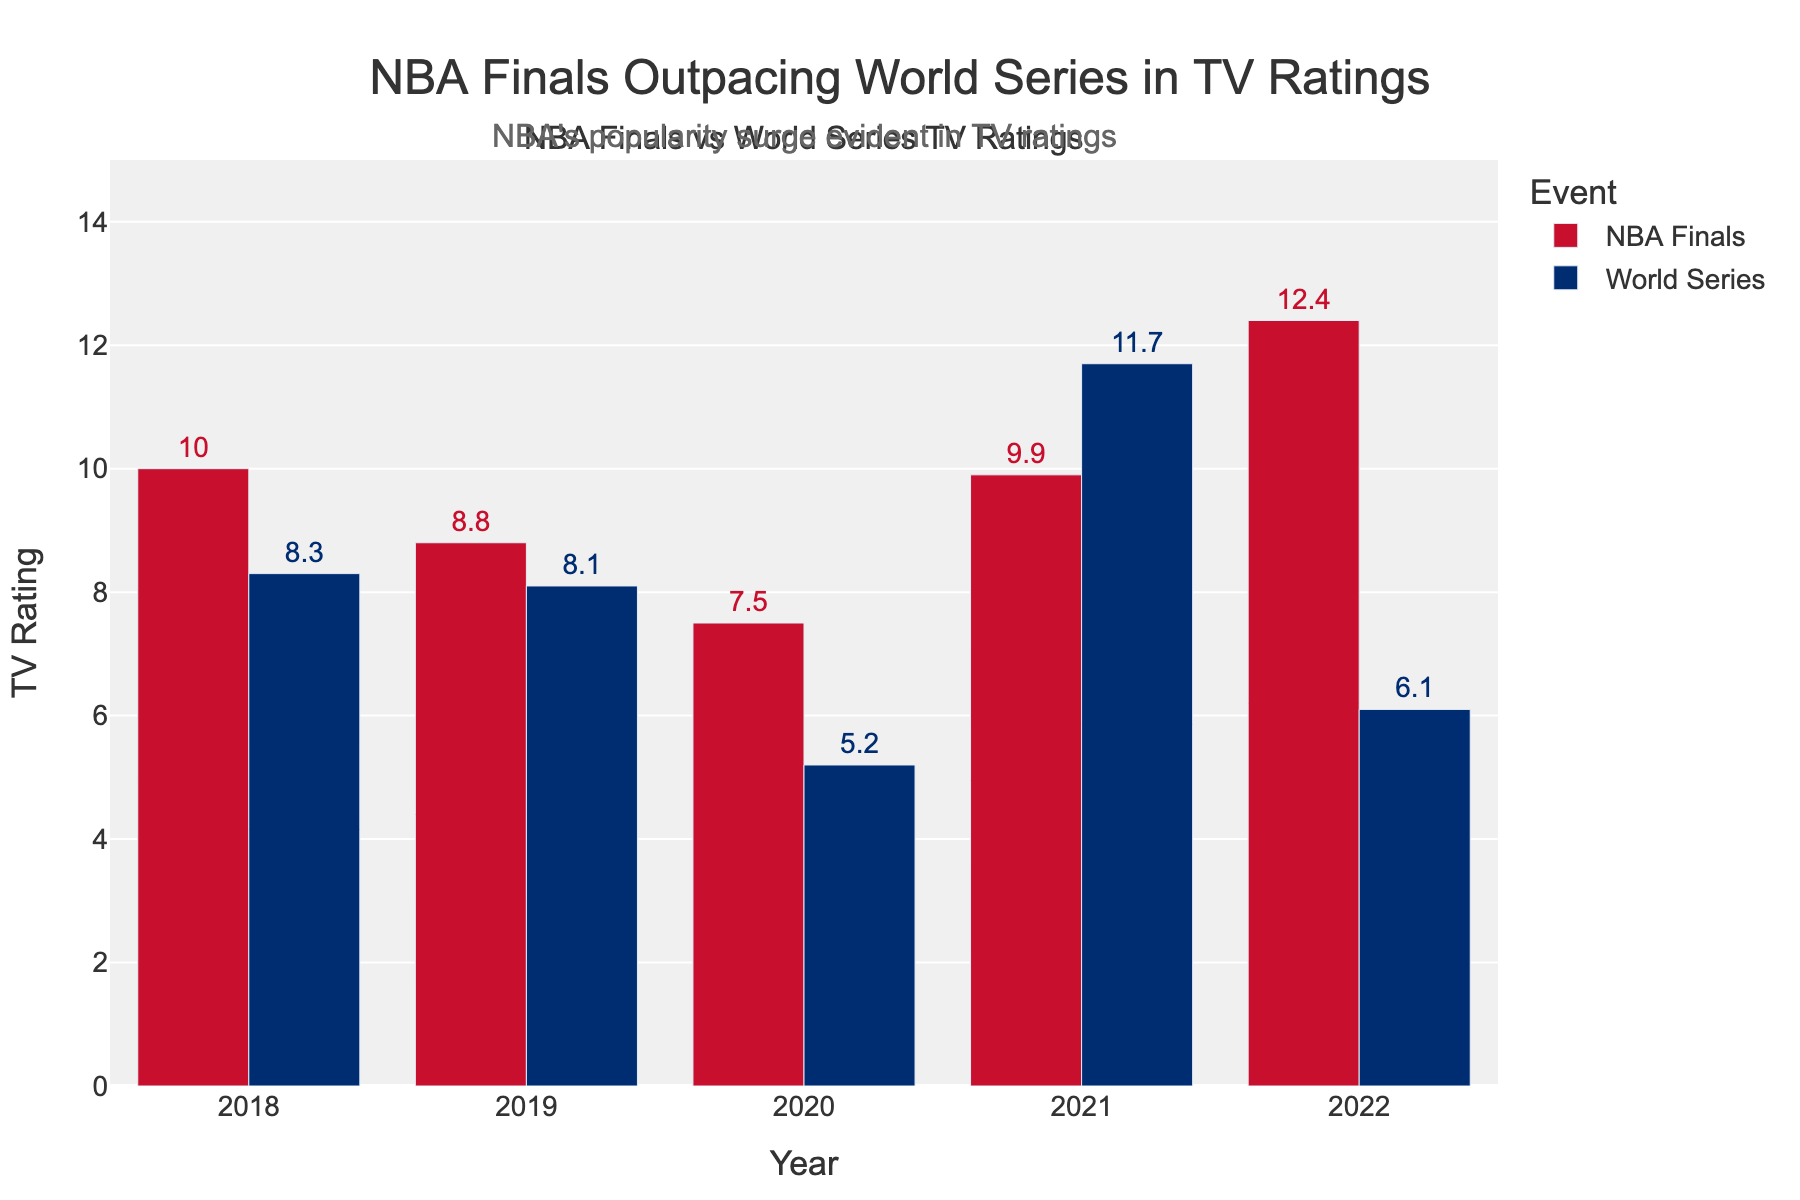What trend is evident from the NBA Finals' TV ratings over the last five years? The NBA Finals' TV ratings exhibit an overall increasing trend from 2018 (10.0) to 2022 (12.4), except for a dip in 2019 (8.8) and 2020 (7.5).
Answer: Increasing trend, with dips in 2019 and 2020 Did the NBA Finals or the World Series have higher TV ratings in 2021? In 2021, the NBA Finals had a rating of 9.9, whereas the World Series had a rating of 11.7, so the World Series had higher ratings.
Answer: World Series Which year observed the highest TV ratings for the NBA Finals? The highest TV rating for the NBA Finals is in 2022 with a rating of 12.4, which is the largest value displayed in the NBA Finals bar chart.
Answer: 2022 How do the TV ratings for the World Series in 2020 compare to those of the NBA Finals in the same year? In 2020, the World Series had a rating of 5.2, while the NBA Finals had a rating of 7.5. Thus, the NBA Finals had a higher rating.
Answer: NBA Finals had higher ratings What's the average TV rating for the NBA Finals over the five years? Sum the ratings for the NBA Finals for each year (10.0 + 8.8 + 7.5 + 9.9 + 12.4) to get 48.6. Divide by the number of years (5) to find the average: 48.6 / 5.
Answer: 9.72 How did the TV ratings change for the World Series from 2018 to 2022? The World Series ratings started at 8.3 in 2018, slightly decreased to 8.1 in 2019, dropped to 5.2 in 2020, increased to 11.7 in 2021, and then significantly decreased to 6.1 in 2022.
Answer: No consistent trend, fluctuating ratings What is the difference in TV ratings between the NBA Finals and the World Series in 2022? The rating for the NBA Finals in 2022 is 12.4, and the rating for the World Series is 6.1. The difference is calculated by subtracting the World Series rating from the NBA Finals rating: 12.4 - 6.1.
Answer: 6.3 What's the combined TV rating total for the NBA Finals and the World Series in 2021? The TV rating for the NBA Finals in 2021 is 9.9, and for the World Series, it is 11.7. Adding these together gives 9.9 + 11.7.
Answer: 21.6 Which event showed the lowest TV rating over the five years, and in which year? By examining the lowest bars on the chart, the lowest TV rating observed is 5.2 for the World Series in 2020.
Answer: World Series, 2020 